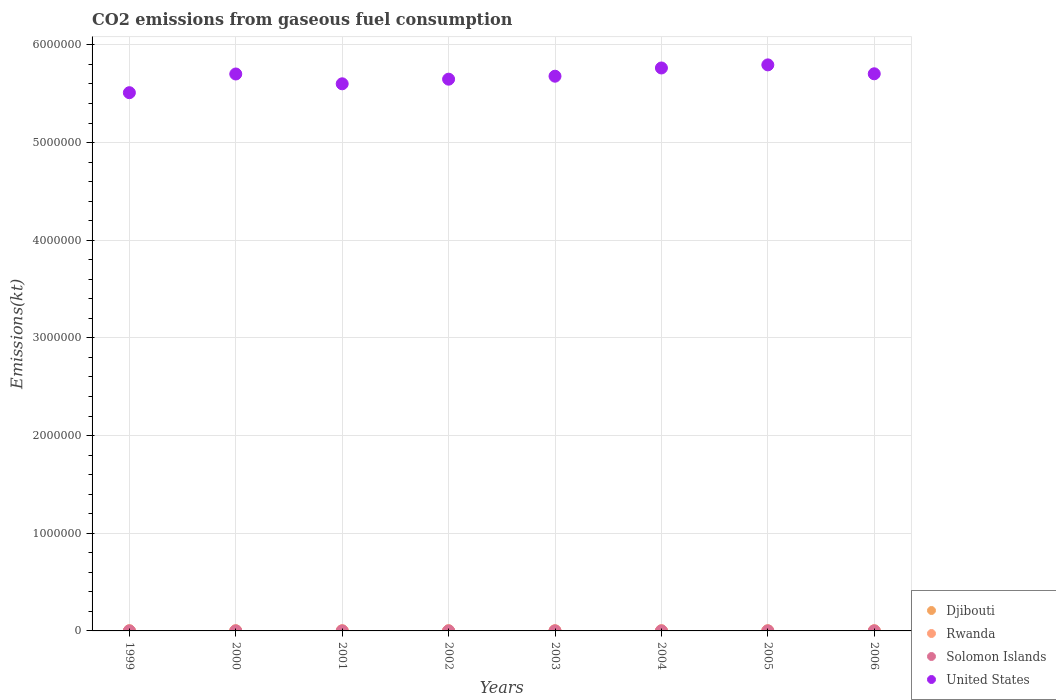How many different coloured dotlines are there?
Your response must be concise. 4. What is the amount of CO2 emitted in Solomon Islands in 2003?
Provide a short and direct response. 179.68. Across all years, what is the maximum amount of CO2 emitted in United States?
Provide a short and direct response. 5.80e+06. Across all years, what is the minimum amount of CO2 emitted in Rwanda?
Give a very brief answer. 509.71. In which year was the amount of CO2 emitted in United States maximum?
Ensure brevity in your answer.  2005. In which year was the amount of CO2 emitted in United States minimum?
Keep it short and to the point. 1999. What is the total amount of CO2 emitted in Djibouti in the graph?
Offer a very short reply. 3197.62. What is the difference between the amount of CO2 emitted in Djibouti in 1999 and that in 2004?
Offer a very short reply. 11. What is the difference between the amount of CO2 emitted in United States in 2001 and the amount of CO2 emitted in Solomon Islands in 2005?
Give a very brief answer. 5.60e+06. What is the average amount of CO2 emitted in Rwanda per year?
Provide a succinct answer. 525.76. In the year 2001, what is the difference between the amount of CO2 emitted in Djibouti and amount of CO2 emitted in Rwanda?
Ensure brevity in your answer.  -205.35. What is the ratio of the amount of CO2 emitted in Rwanda in 2002 to that in 2006?
Your answer should be compact. 1.01. What is the difference between the highest and the second highest amount of CO2 emitted in United States?
Your response must be concise. 3.17e+04. What is the difference between the highest and the lowest amount of CO2 emitted in Rwanda?
Provide a succinct answer. 22. In how many years, is the amount of CO2 emitted in United States greater than the average amount of CO2 emitted in United States taken over all years?
Give a very brief answer. 5. Is it the case that in every year, the sum of the amount of CO2 emitted in Rwanda and amount of CO2 emitted in Solomon Islands  is greater than the amount of CO2 emitted in United States?
Your answer should be compact. No. Is the amount of CO2 emitted in Djibouti strictly greater than the amount of CO2 emitted in Solomon Islands over the years?
Your answer should be very brief. Yes. How many dotlines are there?
Ensure brevity in your answer.  4. Are the values on the major ticks of Y-axis written in scientific E-notation?
Make the answer very short. No. Does the graph contain grids?
Provide a short and direct response. Yes. How many legend labels are there?
Keep it short and to the point. 4. What is the title of the graph?
Ensure brevity in your answer.  CO2 emissions from gaseous fuel consumption. What is the label or title of the Y-axis?
Your answer should be very brief. Emissions(kt). What is the Emissions(kt) in Djibouti in 1999?
Your response must be concise. 421.7. What is the Emissions(kt) in Rwanda in 1999?
Your answer should be very brief. 509.71. What is the Emissions(kt) of Solomon Islands in 1999?
Your answer should be very brief. 165.01. What is the Emissions(kt) in United States in 1999?
Provide a short and direct response. 5.51e+06. What is the Emissions(kt) of Djibouti in 2000?
Provide a succinct answer. 363.03. What is the Emissions(kt) in Rwanda in 2000?
Your answer should be very brief. 528.05. What is the Emissions(kt) of Solomon Islands in 2000?
Give a very brief answer. 165.01. What is the Emissions(kt) of United States in 2000?
Your answer should be compact. 5.70e+06. What is the Emissions(kt) of Djibouti in 2001?
Provide a succinct answer. 326.36. What is the Emissions(kt) of Rwanda in 2001?
Make the answer very short. 531.72. What is the Emissions(kt) in Solomon Islands in 2001?
Your answer should be very brief. 172.35. What is the Emissions(kt) of United States in 2001?
Your answer should be compact. 5.60e+06. What is the Emissions(kt) of Djibouti in 2002?
Offer a terse response. 407.04. What is the Emissions(kt) of Rwanda in 2002?
Give a very brief answer. 531.72. What is the Emissions(kt) in Solomon Islands in 2002?
Ensure brevity in your answer.  172.35. What is the Emissions(kt) in United States in 2002?
Offer a very short reply. 5.65e+06. What is the Emissions(kt) of Djibouti in 2003?
Your answer should be compact. 429.04. What is the Emissions(kt) in Rwanda in 2003?
Keep it short and to the point. 520.71. What is the Emissions(kt) in Solomon Islands in 2003?
Keep it short and to the point. 179.68. What is the Emissions(kt) of United States in 2003?
Ensure brevity in your answer.  5.68e+06. What is the Emissions(kt) of Djibouti in 2004?
Make the answer very short. 410.7. What is the Emissions(kt) in Rwanda in 2004?
Your answer should be compact. 528.05. What is the Emissions(kt) in Solomon Islands in 2004?
Your answer should be compact. 179.68. What is the Emissions(kt) in United States in 2004?
Offer a terse response. 5.76e+06. What is the Emissions(kt) in Djibouti in 2005?
Provide a succinct answer. 421.7. What is the Emissions(kt) in Rwanda in 2005?
Offer a very short reply. 528.05. What is the Emissions(kt) of Solomon Islands in 2005?
Make the answer very short. 179.68. What is the Emissions(kt) of United States in 2005?
Ensure brevity in your answer.  5.80e+06. What is the Emissions(kt) in Djibouti in 2006?
Offer a terse response. 418.04. What is the Emissions(kt) in Rwanda in 2006?
Provide a succinct answer. 528.05. What is the Emissions(kt) of Solomon Islands in 2006?
Offer a terse response. 179.68. What is the Emissions(kt) in United States in 2006?
Provide a short and direct response. 5.70e+06. Across all years, what is the maximum Emissions(kt) of Djibouti?
Keep it short and to the point. 429.04. Across all years, what is the maximum Emissions(kt) in Rwanda?
Give a very brief answer. 531.72. Across all years, what is the maximum Emissions(kt) of Solomon Islands?
Give a very brief answer. 179.68. Across all years, what is the maximum Emissions(kt) of United States?
Ensure brevity in your answer.  5.80e+06. Across all years, what is the minimum Emissions(kt) in Djibouti?
Provide a short and direct response. 326.36. Across all years, what is the minimum Emissions(kt) of Rwanda?
Your answer should be very brief. 509.71. Across all years, what is the minimum Emissions(kt) of Solomon Islands?
Make the answer very short. 165.01. Across all years, what is the minimum Emissions(kt) of United States?
Ensure brevity in your answer.  5.51e+06. What is the total Emissions(kt) of Djibouti in the graph?
Give a very brief answer. 3197.62. What is the total Emissions(kt) of Rwanda in the graph?
Offer a very short reply. 4206.05. What is the total Emissions(kt) of Solomon Islands in the graph?
Ensure brevity in your answer.  1393.46. What is the total Emissions(kt) of United States in the graph?
Ensure brevity in your answer.  4.54e+07. What is the difference between the Emissions(kt) of Djibouti in 1999 and that in 2000?
Ensure brevity in your answer.  58.67. What is the difference between the Emissions(kt) in Rwanda in 1999 and that in 2000?
Give a very brief answer. -18.34. What is the difference between the Emissions(kt) in Solomon Islands in 1999 and that in 2000?
Give a very brief answer. 0. What is the difference between the Emissions(kt) in United States in 1999 and that in 2000?
Your answer should be compact. -1.91e+05. What is the difference between the Emissions(kt) in Djibouti in 1999 and that in 2001?
Offer a terse response. 95.34. What is the difference between the Emissions(kt) in Rwanda in 1999 and that in 2001?
Provide a succinct answer. -22. What is the difference between the Emissions(kt) of Solomon Islands in 1999 and that in 2001?
Offer a very short reply. -7.33. What is the difference between the Emissions(kt) of United States in 1999 and that in 2001?
Your answer should be very brief. -9.10e+04. What is the difference between the Emissions(kt) of Djibouti in 1999 and that in 2002?
Offer a very short reply. 14.67. What is the difference between the Emissions(kt) in Rwanda in 1999 and that in 2002?
Offer a very short reply. -22. What is the difference between the Emissions(kt) of Solomon Islands in 1999 and that in 2002?
Your response must be concise. -7.33. What is the difference between the Emissions(kt) in United States in 1999 and that in 2002?
Provide a short and direct response. -1.38e+05. What is the difference between the Emissions(kt) in Djibouti in 1999 and that in 2003?
Give a very brief answer. -7.33. What is the difference between the Emissions(kt) in Rwanda in 1999 and that in 2003?
Give a very brief answer. -11. What is the difference between the Emissions(kt) in Solomon Islands in 1999 and that in 2003?
Provide a succinct answer. -14.67. What is the difference between the Emissions(kt) in United States in 1999 and that in 2003?
Provide a short and direct response. -1.69e+05. What is the difference between the Emissions(kt) in Djibouti in 1999 and that in 2004?
Make the answer very short. 11. What is the difference between the Emissions(kt) in Rwanda in 1999 and that in 2004?
Make the answer very short. -18.34. What is the difference between the Emissions(kt) in Solomon Islands in 1999 and that in 2004?
Offer a terse response. -14.67. What is the difference between the Emissions(kt) in United States in 1999 and that in 2004?
Provide a succinct answer. -2.53e+05. What is the difference between the Emissions(kt) in Rwanda in 1999 and that in 2005?
Keep it short and to the point. -18.34. What is the difference between the Emissions(kt) of Solomon Islands in 1999 and that in 2005?
Your response must be concise. -14.67. What is the difference between the Emissions(kt) of United States in 1999 and that in 2005?
Offer a very short reply. -2.85e+05. What is the difference between the Emissions(kt) in Djibouti in 1999 and that in 2006?
Your answer should be very brief. 3.67. What is the difference between the Emissions(kt) in Rwanda in 1999 and that in 2006?
Provide a succinct answer. -18.34. What is the difference between the Emissions(kt) of Solomon Islands in 1999 and that in 2006?
Provide a short and direct response. -14.67. What is the difference between the Emissions(kt) of United States in 1999 and that in 2006?
Ensure brevity in your answer.  -1.93e+05. What is the difference between the Emissions(kt) of Djibouti in 2000 and that in 2001?
Make the answer very short. 36.67. What is the difference between the Emissions(kt) in Rwanda in 2000 and that in 2001?
Keep it short and to the point. -3.67. What is the difference between the Emissions(kt) of Solomon Islands in 2000 and that in 2001?
Give a very brief answer. -7.33. What is the difference between the Emissions(kt) in United States in 2000 and that in 2001?
Your response must be concise. 1.00e+05. What is the difference between the Emissions(kt) in Djibouti in 2000 and that in 2002?
Your response must be concise. -44. What is the difference between the Emissions(kt) of Rwanda in 2000 and that in 2002?
Your answer should be very brief. -3.67. What is the difference between the Emissions(kt) in Solomon Islands in 2000 and that in 2002?
Make the answer very short. -7.33. What is the difference between the Emissions(kt) in United States in 2000 and that in 2002?
Provide a succinct answer. 5.31e+04. What is the difference between the Emissions(kt) of Djibouti in 2000 and that in 2003?
Make the answer very short. -66.01. What is the difference between the Emissions(kt) in Rwanda in 2000 and that in 2003?
Your response must be concise. 7.33. What is the difference between the Emissions(kt) of Solomon Islands in 2000 and that in 2003?
Offer a very short reply. -14.67. What is the difference between the Emissions(kt) of United States in 2000 and that in 2003?
Your answer should be very brief. 2.26e+04. What is the difference between the Emissions(kt) of Djibouti in 2000 and that in 2004?
Keep it short and to the point. -47.67. What is the difference between the Emissions(kt) in Solomon Islands in 2000 and that in 2004?
Offer a very short reply. -14.67. What is the difference between the Emissions(kt) of United States in 2000 and that in 2004?
Provide a short and direct response. -6.16e+04. What is the difference between the Emissions(kt) in Djibouti in 2000 and that in 2005?
Provide a short and direct response. -58.67. What is the difference between the Emissions(kt) of Solomon Islands in 2000 and that in 2005?
Provide a succinct answer. -14.67. What is the difference between the Emissions(kt) in United States in 2000 and that in 2005?
Your answer should be very brief. -9.33e+04. What is the difference between the Emissions(kt) of Djibouti in 2000 and that in 2006?
Give a very brief answer. -55.01. What is the difference between the Emissions(kt) in Rwanda in 2000 and that in 2006?
Provide a short and direct response. 0. What is the difference between the Emissions(kt) of Solomon Islands in 2000 and that in 2006?
Give a very brief answer. -14.67. What is the difference between the Emissions(kt) in United States in 2000 and that in 2006?
Your answer should be very brief. -2042.52. What is the difference between the Emissions(kt) of Djibouti in 2001 and that in 2002?
Make the answer very short. -80.67. What is the difference between the Emissions(kt) of United States in 2001 and that in 2002?
Give a very brief answer. -4.73e+04. What is the difference between the Emissions(kt) in Djibouti in 2001 and that in 2003?
Give a very brief answer. -102.68. What is the difference between the Emissions(kt) of Rwanda in 2001 and that in 2003?
Offer a very short reply. 11. What is the difference between the Emissions(kt) of Solomon Islands in 2001 and that in 2003?
Your response must be concise. -7.33. What is the difference between the Emissions(kt) of United States in 2001 and that in 2003?
Ensure brevity in your answer.  -7.78e+04. What is the difference between the Emissions(kt) of Djibouti in 2001 and that in 2004?
Ensure brevity in your answer.  -84.34. What is the difference between the Emissions(kt) in Rwanda in 2001 and that in 2004?
Provide a short and direct response. 3.67. What is the difference between the Emissions(kt) of Solomon Islands in 2001 and that in 2004?
Offer a terse response. -7.33. What is the difference between the Emissions(kt) in United States in 2001 and that in 2004?
Make the answer very short. -1.62e+05. What is the difference between the Emissions(kt) in Djibouti in 2001 and that in 2005?
Ensure brevity in your answer.  -95.34. What is the difference between the Emissions(kt) of Rwanda in 2001 and that in 2005?
Give a very brief answer. 3.67. What is the difference between the Emissions(kt) of Solomon Islands in 2001 and that in 2005?
Offer a very short reply. -7.33. What is the difference between the Emissions(kt) of United States in 2001 and that in 2005?
Offer a terse response. -1.94e+05. What is the difference between the Emissions(kt) in Djibouti in 2001 and that in 2006?
Offer a terse response. -91.67. What is the difference between the Emissions(kt) in Rwanda in 2001 and that in 2006?
Your response must be concise. 3.67. What is the difference between the Emissions(kt) of Solomon Islands in 2001 and that in 2006?
Your answer should be compact. -7.33. What is the difference between the Emissions(kt) in United States in 2001 and that in 2006?
Provide a succinct answer. -1.02e+05. What is the difference between the Emissions(kt) in Djibouti in 2002 and that in 2003?
Provide a succinct answer. -22. What is the difference between the Emissions(kt) in Rwanda in 2002 and that in 2003?
Give a very brief answer. 11. What is the difference between the Emissions(kt) of Solomon Islands in 2002 and that in 2003?
Keep it short and to the point. -7.33. What is the difference between the Emissions(kt) of United States in 2002 and that in 2003?
Your answer should be very brief. -3.05e+04. What is the difference between the Emissions(kt) of Djibouti in 2002 and that in 2004?
Keep it short and to the point. -3.67. What is the difference between the Emissions(kt) of Rwanda in 2002 and that in 2004?
Ensure brevity in your answer.  3.67. What is the difference between the Emissions(kt) in Solomon Islands in 2002 and that in 2004?
Provide a succinct answer. -7.33. What is the difference between the Emissions(kt) of United States in 2002 and that in 2004?
Your answer should be compact. -1.15e+05. What is the difference between the Emissions(kt) of Djibouti in 2002 and that in 2005?
Your answer should be compact. -14.67. What is the difference between the Emissions(kt) of Rwanda in 2002 and that in 2005?
Keep it short and to the point. 3.67. What is the difference between the Emissions(kt) of Solomon Islands in 2002 and that in 2005?
Provide a succinct answer. -7.33. What is the difference between the Emissions(kt) in United States in 2002 and that in 2005?
Provide a short and direct response. -1.46e+05. What is the difference between the Emissions(kt) of Djibouti in 2002 and that in 2006?
Your response must be concise. -11. What is the difference between the Emissions(kt) of Rwanda in 2002 and that in 2006?
Give a very brief answer. 3.67. What is the difference between the Emissions(kt) of Solomon Islands in 2002 and that in 2006?
Provide a succinct answer. -7.33. What is the difference between the Emissions(kt) in United States in 2002 and that in 2006?
Keep it short and to the point. -5.51e+04. What is the difference between the Emissions(kt) of Djibouti in 2003 and that in 2004?
Make the answer very short. 18.34. What is the difference between the Emissions(kt) of Rwanda in 2003 and that in 2004?
Offer a very short reply. -7.33. What is the difference between the Emissions(kt) of Solomon Islands in 2003 and that in 2004?
Offer a terse response. 0. What is the difference between the Emissions(kt) in United States in 2003 and that in 2004?
Provide a succinct answer. -8.42e+04. What is the difference between the Emissions(kt) in Djibouti in 2003 and that in 2005?
Make the answer very short. 7.33. What is the difference between the Emissions(kt) of Rwanda in 2003 and that in 2005?
Your answer should be compact. -7.33. What is the difference between the Emissions(kt) of United States in 2003 and that in 2005?
Keep it short and to the point. -1.16e+05. What is the difference between the Emissions(kt) of Djibouti in 2003 and that in 2006?
Provide a succinct answer. 11. What is the difference between the Emissions(kt) of Rwanda in 2003 and that in 2006?
Keep it short and to the point. -7.33. What is the difference between the Emissions(kt) in United States in 2003 and that in 2006?
Your answer should be very brief. -2.46e+04. What is the difference between the Emissions(kt) in Djibouti in 2004 and that in 2005?
Offer a terse response. -11. What is the difference between the Emissions(kt) in Rwanda in 2004 and that in 2005?
Make the answer very short. 0. What is the difference between the Emissions(kt) in United States in 2004 and that in 2005?
Your answer should be very brief. -3.17e+04. What is the difference between the Emissions(kt) of Djibouti in 2004 and that in 2006?
Provide a succinct answer. -7.33. What is the difference between the Emissions(kt) of Rwanda in 2004 and that in 2006?
Offer a terse response. 0. What is the difference between the Emissions(kt) of Solomon Islands in 2004 and that in 2006?
Provide a succinct answer. 0. What is the difference between the Emissions(kt) of United States in 2004 and that in 2006?
Offer a very short reply. 5.96e+04. What is the difference between the Emissions(kt) of Djibouti in 2005 and that in 2006?
Offer a very short reply. 3.67. What is the difference between the Emissions(kt) of Rwanda in 2005 and that in 2006?
Your answer should be very brief. 0. What is the difference between the Emissions(kt) of Solomon Islands in 2005 and that in 2006?
Give a very brief answer. 0. What is the difference between the Emissions(kt) in United States in 2005 and that in 2006?
Give a very brief answer. 9.13e+04. What is the difference between the Emissions(kt) in Djibouti in 1999 and the Emissions(kt) in Rwanda in 2000?
Give a very brief answer. -106.34. What is the difference between the Emissions(kt) of Djibouti in 1999 and the Emissions(kt) of Solomon Islands in 2000?
Make the answer very short. 256.69. What is the difference between the Emissions(kt) of Djibouti in 1999 and the Emissions(kt) of United States in 2000?
Ensure brevity in your answer.  -5.70e+06. What is the difference between the Emissions(kt) in Rwanda in 1999 and the Emissions(kt) in Solomon Islands in 2000?
Your answer should be compact. 344.7. What is the difference between the Emissions(kt) in Rwanda in 1999 and the Emissions(kt) in United States in 2000?
Your answer should be very brief. -5.70e+06. What is the difference between the Emissions(kt) in Solomon Islands in 1999 and the Emissions(kt) in United States in 2000?
Provide a succinct answer. -5.70e+06. What is the difference between the Emissions(kt) of Djibouti in 1999 and the Emissions(kt) of Rwanda in 2001?
Keep it short and to the point. -110.01. What is the difference between the Emissions(kt) in Djibouti in 1999 and the Emissions(kt) in Solomon Islands in 2001?
Offer a very short reply. 249.36. What is the difference between the Emissions(kt) of Djibouti in 1999 and the Emissions(kt) of United States in 2001?
Ensure brevity in your answer.  -5.60e+06. What is the difference between the Emissions(kt) in Rwanda in 1999 and the Emissions(kt) in Solomon Islands in 2001?
Provide a succinct answer. 337.36. What is the difference between the Emissions(kt) of Rwanda in 1999 and the Emissions(kt) of United States in 2001?
Keep it short and to the point. -5.60e+06. What is the difference between the Emissions(kt) in Solomon Islands in 1999 and the Emissions(kt) in United States in 2001?
Make the answer very short. -5.60e+06. What is the difference between the Emissions(kt) in Djibouti in 1999 and the Emissions(kt) in Rwanda in 2002?
Provide a short and direct response. -110.01. What is the difference between the Emissions(kt) of Djibouti in 1999 and the Emissions(kt) of Solomon Islands in 2002?
Your response must be concise. 249.36. What is the difference between the Emissions(kt) of Djibouti in 1999 and the Emissions(kt) of United States in 2002?
Your answer should be compact. -5.65e+06. What is the difference between the Emissions(kt) of Rwanda in 1999 and the Emissions(kt) of Solomon Islands in 2002?
Provide a succinct answer. 337.36. What is the difference between the Emissions(kt) of Rwanda in 1999 and the Emissions(kt) of United States in 2002?
Make the answer very short. -5.65e+06. What is the difference between the Emissions(kt) in Solomon Islands in 1999 and the Emissions(kt) in United States in 2002?
Offer a terse response. -5.65e+06. What is the difference between the Emissions(kt) in Djibouti in 1999 and the Emissions(kt) in Rwanda in 2003?
Your response must be concise. -99.01. What is the difference between the Emissions(kt) in Djibouti in 1999 and the Emissions(kt) in Solomon Islands in 2003?
Provide a short and direct response. 242.02. What is the difference between the Emissions(kt) in Djibouti in 1999 and the Emissions(kt) in United States in 2003?
Make the answer very short. -5.68e+06. What is the difference between the Emissions(kt) of Rwanda in 1999 and the Emissions(kt) of Solomon Islands in 2003?
Make the answer very short. 330.03. What is the difference between the Emissions(kt) of Rwanda in 1999 and the Emissions(kt) of United States in 2003?
Offer a terse response. -5.68e+06. What is the difference between the Emissions(kt) in Solomon Islands in 1999 and the Emissions(kt) in United States in 2003?
Offer a terse response. -5.68e+06. What is the difference between the Emissions(kt) in Djibouti in 1999 and the Emissions(kt) in Rwanda in 2004?
Your answer should be compact. -106.34. What is the difference between the Emissions(kt) in Djibouti in 1999 and the Emissions(kt) in Solomon Islands in 2004?
Your answer should be very brief. 242.02. What is the difference between the Emissions(kt) in Djibouti in 1999 and the Emissions(kt) in United States in 2004?
Your response must be concise. -5.76e+06. What is the difference between the Emissions(kt) of Rwanda in 1999 and the Emissions(kt) of Solomon Islands in 2004?
Your answer should be very brief. 330.03. What is the difference between the Emissions(kt) of Rwanda in 1999 and the Emissions(kt) of United States in 2004?
Your answer should be very brief. -5.76e+06. What is the difference between the Emissions(kt) of Solomon Islands in 1999 and the Emissions(kt) of United States in 2004?
Ensure brevity in your answer.  -5.76e+06. What is the difference between the Emissions(kt) in Djibouti in 1999 and the Emissions(kt) in Rwanda in 2005?
Make the answer very short. -106.34. What is the difference between the Emissions(kt) in Djibouti in 1999 and the Emissions(kt) in Solomon Islands in 2005?
Your answer should be very brief. 242.02. What is the difference between the Emissions(kt) of Djibouti in 1999 and the Emissions(kt) of United States in 2005?
Provide a short and direct response. -5.79e+06. What is the difference between the Emissions(kt) in Rwanda in 1999 and the Emissions(kt) in Solomon Islands in 2005?
Ensure brevity in your answer.  330.03. What is the difference between the Emissions(kt) of Rwanda in 1999 and the Emissions(kt) of United States in 2005?
Offer a very short reply. -5.79e+06. What is the difference between the Emissions(kt) of Solomon Islands in 1999 and the Emissions(kt) of United States in 2005?
Offer a terse response. -5.79e+06. What is the difference between the Emissions(kt) in Djibouti in 1999 and the Emissions(kt) in Rwanda in 2006?
Offer a very short reply. -106.34. What is the difference between the Emissions(kt) of Djibouti in 1999 and the Emissions(kt) of Solomon Islands in 2006?
Keep it short and to the point. 242.02. What is the difference between the Emissions(kt) of Djibouti in 1999 and the Emissions(kt) of United States in 2006?
Keep it short and to the point. -5.70e+06. What is the difference between the Emissions(kt) in Rwanda in 1999 and the Emissions(kt) in Solomon Islands in 2006?
Your answer should be compact. 330.03. What is the difference between the Emissions(kt) in Rwanda in 1999 and the Emissions(kt) in United States in 2006?
Ensure brevity in your answer.  -5.70e+06. What is the difference between the Emissions(kt) of Solomon Islands in 1999 and the Emissions(kt) of United States in 2006?
Provide a succinct answer. -5.70e+06. What is the difference between the Emissions(kt) in Djibouti in 2000 and the Emissions(kt) in Rwanda in 2001?
Provide a succinct answer. -168.68. What is the difference between the Emissions(kt) of Djibouti in 2000 and the Emissions(kt) of Solomon Islands in 2001?
Ensure brevity in your answer.  190.68. What is the difference between the Emissions(kt) in Djibouti in 2000 and the Emissions(kt) in United States in 2001?
Your response must be concise. -5.60e+06. What is the difference between the Emissions(kt) in Rwanda in 2000 and the Emissions(kt) in Solomon Islands in 2001?
Provide a succinct answer. 355.7. What is the difference between the Emissions(kt) in Rwanda in 2000 and the Emissions(kt) in United States in 2001?
Make the answer very short. -5.60e+06. What is the difference between the Emissions(kt) of Solomon Islands in 2000 and the Emissions(kt) of United States in 2001?
Make the answer very short. -5.60e+06. What is the difference between the Emissions(kt) in Djibouti in 2000 and the Emissions(kt) in Rwanda in 2002?
Offer a very short reply. -168.68. What is the difference between the Emissions(kt) of Djibouti in 2000 and the Emissions(kt) of Solomon Islands in 2002?
Provide a short and direct response. 190.68. What is the difference between the Emissions(kt) in Djibouti in 2000 and the Emissions(kt) in United States in 2002?
Ensure brevity in your answer.  -5.65e+06. What is the difference between the Emissions(kt) of Rwanda in 2000 and the Emissions(kt) of Solomon Islands in 2002?
Make the answer very short. 355.7. What is the difference between the Emissions(kt) of Rwanda in 2000 and the Emissions(kt) of United States in 2002?
Provide a succinct answer. -5.65e+06. What is the difference between the Emissions(kt) of Solomon Islands in 2000 and the Emissions(kt) of United States in 2002?
Your answer should be compact. -5.65e+06. What is the difference between the Emissions(kt) in Djibouti in 2000 and the Emissions(kt) in Rwanda in 2003?
Offer a very short reply. -157.68. What is the difference between the Emissions(kt) in Djibouti in 2000 and the Emissions(kt) in Solomon Islands in 2003?
Your answer should be compact. 183.35. What is the difference between the Emissions(kt) of Djibouti in 2000 and the Emissions(kt) of United States in 2003?
Offer a terse response. -5.68e+06. What is the difference between the Emissions(kt) of Rwanda in 2000 and the Emissions(kt) of Solomon Islands in 2003?
Offer a terse response. 348.37. What is the difference between the Emissions(kt) of Rwanda in 2000 and the Emissions(kt) of United States in 2003?
Provide a short and direct response. -5.68e+06. What is the difference between the Emissions(kt) of Solomon Islands in 2000 and the Emissions(kt) of United States in 2003?
Offer a terse response. -5.68e+06. What is the difference between the Emissions(kt) of Djibouti in 2000 and the Emissions(kt) of Rwanda in 2004?
Provide a succinct answer. -165.01. What is the difference between the Emissions(kt) of Djibouti in 2000 and the Emissions(kt) of Solomon Islands in 2004?
Offer a terse response. 183.35. What is the difference between the Emissions(kt) of Djibouti in 2000 and the Emissions(kt) of United States in 2004?
Keep it short and to the point. -5.76e+06. What is the difference between the Emissions(kt) in Rwanda in 2000 and the Emissions(kt) in Solomon Islands in 2004?
Provide a succinct answer. 348.37. What is the difference between the Emissions(kt) in Rwanda in 2000 and the Emissions(kt) in United States in 2004?
Ensure brevity in your answer.  -5.76e+06. What is the difference between the Emissions(kt) of Solomon Islands in 2000 and the Emissions(kt) of United States in 2004?
Offer a terse response. -5.76e+06. What is the difference between the Emissions(kt) of Djibouti in 2000 and the Emissions(kt) of Rwanda in 2005?
Your answer should be very brief. -165.01. What is the difference between the Emissions(kt) of Djibouti in 2000 and the Emissions(kt) of Solomon Islands in 2005?
Make the answer very short. 183.35. What is the difference between the Emissions(kt) of Djibouti in 2000 and the Emissions(kt) of United States in 2005?
Your answer should be compact. -5.79e+06. What is the difference between the Emissions(kt) of Rwanda in 2000 and the Emissions(kt) of Solomon Islands in 2005?
Your answer should be very brief. 348.37. What is the difference between the Emissions(kt) of Rwanda in 2000 and the Emissions(kt) of United States in 2005?
Offer a very short reply. -5.79e+06. What is the difference between the Emissions(kt) of Solomon Islands in 2000 and the Emissions(kt) of United States in 2005?
Provide a short and direct response. -5.79e+06. What is the difference between the Emissions(kt) in Djibouti in 2000 and the Emissions(kt) in Rwanda in 2006?
Make the answer very short. -165.01. What is the difference between the Emissions(kt) in Djibouti in 2000 and the Emissions(kt) in Solomon Islands in 2006?
Your answer should be very brief. 183.35. What is the difference between the Emissions(kt) in Djibouti in 2000 and the Emissions(kt) in United States in 2006?
Ensure brevity in your answer.  -5.70e+06. What is the difference between the Emissions(kt) in Rwanda in 2000 and the Emissions(kt) in Solomon Islands in 2006?
Offer a terse response. 348.37. What is the difference between the Emissions(kt) of Rwanda in 2000 and the Emissions(kt) of United States in 2006?
Your answer should be very brief. -5.70e+06. What is the difference between the Emissions(kt) in Solomon Islands in 2000 and the Emissions(kt) in United States in 2006?
Offer a very short reply. -5.70e+06. What is the difference between the Emissions(kt) of Djibouti in 2001 and the Emissions(kt) of Rwanda in 2002?
Provide a short and direct response. -205.35. What is the difference between the Emissions(kt) of Djibouti in 2001 and the Emissions(kt) of Solomon Islands in 2002?
Your answer should be compact. 154.01. What is the difference between the Emissions(kt) in Djibouti in 2001 and the Emissions(kt) in United States in 2002?
Provide a short and direct response. -5.65e+06. What is the difference between the Emissions(kt) of Rwanda in 2001 and the Emissions(kt) of Solomon Islands in 2002?
Ensure brevity in your answer.  359.37. What is the difference between the Emissions(kt) of Rwanda in 2001 and the Emissions(kt) of United States in 2002?
Give a very brief answer. -5.65e+06. What is the difference between the Emissions(kt) in Solomon Islands in 2001 and the Emissions(kt) in United States in 2002?
Ensure brevity in your answer.  -5.65e+06. What is the difference between the Emissions(kt) of Djibouti in 2001 and the Emissions(kt) of Rwanda in 2003?
Provide a short and direct response. -194.35. What is the difference between the Emissions(kt) in Djibouti in 2001 and the Emissions(kt) in Solomon Islands in 2003?
Offer a very short reply. 146.68. What is the difference between the Emissions(kt) in Djibouti in 2001 and the Emissions(kt) in United States in 2003?
Your answer should be compact. -5.68e+06. What is the difference between the Emissions(kt) of Rwanda in 2001 and the Emissions(kt) of Solomon Islands in 2003?
Provide a succinct answer. 352.03. What is the difference between the Emissions(kt) in Rwanda in 2001 and the Emissions(kt) in United States in 2003?
Your answer should be compact. -5.68e+06. What is the difference between the Emissions(kt) of Solomon Islands in 2001 and the Emissions(kt) of United States in 2003?
Give a very brief answer. -5.68e+06. What is the difference between the Emissions(kt) of Djibouti in 2001 and the Emissions(kt) of Rwanda in 2004?
Provide a succinct answer. -201.69. What is the difference between the Emissions(kt) in Djibouti in 2001 and the Emissions(kt) in Solomon Islands in 2004?
Give a very brief answer. 146.68. What is the difference between the Emissions(kt) of Djibouti in 2001 and the Emissions(kt) of United States in 2004?
Provide a succinct answer. -5.76e+06. What is the difference between the Emissions(kt) in Rwanda in 2001 and the Emissions(kt) in Solomon Islands in 2004?
Provide a short and direct response. 352.03. What is the difference between the Emissions(kt) in Rwanda in 2001 and the Emissions(kt) in United States in 2004?
Give a very brief answer. -5.76e+06. What is the difference between the Emissions(kt) in Solomon Islands in 2001 and the Emissions(kt) in United States in 2004?
Your response must be concise. -5.76e+06. What is the difference between the Emissions(kt) in Djibouti in 2001 and the Emissions(kt) in Rwanda in 2005?
Offer a terse response. -201.69. What is the difference between the Emissions(kt) of Djibouti in 2001 and the Emissions(kt) of Solomon Islands in 2005?
Offer a terse response. 146.68. What is the difference between the Emissions(kt) of Djibouti in 2001 and the Emissions(kt) of United States in 2005?
Ensure brevity in your answer.  -5.79e+06. What is the difference between the Emissions(kt) of Rwanda in 2001 and the Emissions(kt) of Solomon Islands in 2005?
Your answer should be compact. 352.03. What is the difference between the Emissions(kt) in Rwanda in 2001 and the Emissions(kt) in United States in 2005?
Keep it short and to the point. -5.79e+06. What is the difference between the Emissions(kt) of Solomon Islands in 2001 and the Emissions(kt) of United States in 2005?
Offer a terse response. -5.79e+06. What is the difference between the Emissions(kt) of Djibouti in 2001 and the Emissions(kt) of Rwanda in 2006?
Provide a succinct answer. -201.69. What is the difference between the Emissions(kt) in Djibouti in 2001 and the Emissions(kt) in Solomon Islands in 2006?
Keep it short and to the point. 146.68. What is the difference between the Emissions(kt) of Djibouti in 2001 and the Emissions(kt) of United States in 2006?
Your answer should be very brief. -5.70e+06. What is the difference between the Emissions(kt) in Rwanda in 2001 and the Emissions(kt) in Solomon Islands in 2006?
Keep it short and to the point. 352.03. What is the difference between the Emissions(kt) in Rwanda in 2001 and the Emissions(kt) in United States in 2006?
Offer a very short reply. -5.70e+06. What is the difference between the Emissions(kt) of Solomon Islands in 2001 and the Emissions(kt) of United States in 2006?
Provide a succinct answer. -5.70e+06. What is the difference between the Emissions(kt) in Djibouti in 2002 and the Emissions(kt) in Rwanda in 2003?
Your answer should be very brief. -113.68. What is the difference between the Emissions(kt) of Djibouti in 2002 and the Emissions(kt) of Solomon Islands in 2003?
Keep it short and to the point. 227.35. What is the difference between the Emissions(kt) of Djibouti in 2002 and the Emissions(kt) of United States in 2003?
Your answer should be very brief. -5.68e+06. What is the difference between the Emissions(kt) in Rwanda in 2002 and the Emissions(kt) in Solomon Islands in 2003?
Your answer should be compact. 352.03. What is the difference between the Emissions(kt) of Rwanda in 2002 and the Emissions(kt) of United States in 2003?
Keep it short and to the point. -5.68e+06. What is the difference between the Emissions(kt) in Solomon Islands in 2002 and the Emissions(kt) in United States in 2003?
Make the answer very short. -5.68e+06. What is the difference between the Emissions(kt) in Djibouti in 2002 and the Emissions(kt) in Rwanda in 2004?
Provide a succinct answer. -121.01. What is the difference between the Emissions(kt) of Djibouti in 2002 and the Emissions(kt) of Solomon Islands in 2004?
Make the answer very short. 227.35. What is the difference between the Emissions(kt) in Djibouti in 2002 and the Emissions(kt) in United States in 2004?
Your answer should be compact. -5.76e+06. What is the difference between the Emissions(kt) of Rwanda in 2002 and the Emissions(kt) of Solomon Islands in 2004?
Make the answer very short. 352.03. What is the difference between the Emissions(kt) in Rwanda in 2002 and the Emissions(kt) in United States in 2004?
Offer a terse response. -5.76e+06. What is the difference between the Emissions(kt) in Solomon Islands in 2002 and the Emissions(kt) in United States in 2004?
Keep it short and to the point. -5.76e+06. What is the difference between the Emissions(kt) of Djibouti in 2002 and the Emissions(kt) of Rwanda in 2005?
Give a very brief answer. -121.01. What is the difference between the Emissions(kt) of Djibouti in 2002 and the Emissions(kt) of Solomon Islands in 2005?
Make the answer very short. 227.35. What is the difference between the Emissions(kt) in Djibouti in 2002 and the Emissions(kt) in United States in 2005?
Offer a very short reply. -5.79e+06. What is the difference between the Emissions(kt) in Rwanda in 2002 and the Emissions(kt) in Solomon Islands in 2005?
Your response must be concise. 352.03. What is the difference between the Emissions(kt) of Rwanda in 2002 and the Emissions(kt) of United States in 2005?
Provide a succinct answer. -5.79e+06. What is the difference between the Emissions(kt) in Solomon Islands in 2002 and the Emissions(kt) in United States in 2005?
Keep it short and to the point. -5.79e+06. What is the difference between the Emissions(kt) in Djibouti in 2002 and the Emissions(kt) in Rwanda in 2006?
Your answer should be compact. -121.01. What is the difference between the Emissions(kt) of Djibouti in 2002 and the Emissions(kt) of Solomon Islands in 2006?
Provide a succinct answer. 227.35. What is the difference between the Emissions(kt) of Djibouti in 2002 and the Emissions(kt) of United States in 2006?
Offer a very short reply. -5.70e+06. What is the difference between the Emissions(kt) of Rwanda in 2002 and the Emissions(kt) of Solomon Islands in 2006?
Your answer should be compact. 352.03. What is the difference between the Emissions(kt) in Rwanda in 2002 and the Emissions(kt) in United States in 2006?
Your answer should be very brief. -5.70e+06. What is the difference between the Emissions(kt) in Solomon Islands in 2002 and the Emissions(kt) in United States in 2006?
Keep it short and to the point. -5.70e+06. What is the difference between the Emissions(kt) of Djibouti in 2003 and the Emissions(kt) of Rwanda in 2004?
Ensure brevity in your answer.  -99.01. What is the difference between the Emissions(kt) in Djibouti in 2003 and the Emissions(kt) in Solomon Islands in 2004?
Provide a succinct answer. 249.36. What is the difference between the Emissions(kt) of Djibouti in 2003 and the Emissions(kt) of United States in 2004?
Offer a terse response. -5.76e+06. What is the difference between the Emissions(kt) in Rwanda in 2003 and the Emissions(kt) in Solomon Islands in 2004?
Your answer should be very brief. 341.03. What is the difference between the Emissions(kt) of Rwanda in 2003 and the Emissions(kt) of United States in 2004?
Ensure brevity in your answer.  -5.76e+06. What is the difference between the Emissions(kt) in Solomon Islands in 2003 and the Emissions(kt) in United States in 2004?
Provide a succinct answer. -5.76e+06. What is the difference between the Emissions(kt) in Djibouti in 2003 and the Emissions(kt) in Rwanda in 2005?
Give a very brief answer. -99.01. What is the difference between the Emissions(kt) in Djibouti in 2003 and the Emissions(kt) in Solomon Islands in 2005?
Keep it short and to the point. 249.36. What is the difference between the Emissions(kt) of Djibouti in 2003 and the Emissions(kt) of United States in 2005?
Offer a very short reply. -5.79e+06. What is the difference between the Emissions(kt) in Rwanda in 2003 and the Emissions(kt) in Solomon Islands in 2005?
Make the answer very short. 341.03. What is the difference between the Emissions(kt) of Rwanda in 2003 and the Emissions(kt) of United States in 2005?
Your answer should be very brief. -5.79e+06. What is the difference between the Emissions(kt) of Solomon Islands in 2003 and the Emissions(kt) of United States in 2005?
Provide a short and direct response. -5.79e+06. What is the difference between the Emissions(kt) of Djibouti in 2003 and the Emissions(kt) of Rwanda in 2006?
Provide a succinct answer. -99.01. What is the difference between the Emissions(kt) in Djibouti in 2003 and the Emissions(kt) in Solomon Islands in 2006?
Provide a short and direct response. 249.36. What is the difference between the Emissions(kt) in Djibouti in 2003 and the Emissions(kt) in United States in 2006?
Your answer should be compact. -5.70e+06. What is the difference between the Emissions(kt) of Rwanda in 2003 and the Emissions(kt) of Solomon Islands in 2006?
Make the answer very short. 341.03. What is the difference between the Emissions(kt) in Rwanda in 2003 and the Emissions(kt) in United States in 2006?
Provide a short and direct response. -5.70e+06. What is the difference between the Emissions(kt) of Solomon Islands in 2003 and the Emissions(kt) of United States in 2006?
Provide a short and direct response. -5.70e+06. What is the difference between the Emissions(kt) in Djibouti in 2004 and the Emissions(kt) in Rwanda in 2005?
Ensure brevity in your answer.  -117.34. What is the difference between the Emissions(kt) of Djibouti in 2004 and the Emissions(kt) of Solomon Islands in 2005?
Your answer should be very brief. 231.02. What is the difference between the Emissions(kt) of Djibouti in 2004 and the Emissions(kt) of United States in 2005?
Provide a short and direct response. -5.79e+06. What is the difference between the Emissions(kt) of Rwanda in 2004 and the Emissions(kt) of Solomon Islands in 2005?
Offer a very short reply. 348.37. What is the difference between the Emissions(kt) in Rwanda in 2004 and the Emissions(kt) in United States in 2005?
Provide a short and direct response. -5.79e+06. What is the difference between the Emissions(kt) in Solomon Islands in 2004 and the Emissions(kt) in United States in 2005?
Offer a very short reply. -5.79e+06. What is the difference between the Emissions(kt) of Djibouti in 2004 and the Emissions(kt) of Rwanda in 2006?
Offer a terse response. -117.34. What is the difference between the Emissions(kt) of Djibouti in 2004 and the Emissions(kt) of Solomon Islands in 2006?
Provide a short and direct response. 231.02. What is the difference between the Emissions(kt) in Djibouti in 2004 and the Emissions(kt) in United States in 2006?
Your answer should be compact. -5.70e+06. What is the difference between the Emissions(kt) in Rwanda in 2004 and the Emissions(kt) in Solomon Islands in 2006?
Keep it short and to the point. 348.37. What is the difference between the Emissions(kt) in Rwanda in 2004 and the Emissions(kt) in United States in 2006?
Your answer should be very brief. -5.70e+06. What is the difference between the Emissions(kt) in Solomon Islands in 2004 and the Emissions(kt) in United States in 2006?
Give a very brief answer. -5.70e+06. What is the difference between the Emissions(kt) in Djibouti in 2005 and the Emissions(kt) in Rwanda in 2006?
Make the answer very short. -106.34. What is the difference between the Emissions(kt) of Djibouti in 2005 and the Emissions(kt) of Solomon Islands in 2006?
Give a very brief answer. 242.02. What is the difference between the Emissions(kt) of Djibouti in 2005 and the Emissions(kt) of United States in 2006?
Provide a succinct answer. -5.70e+06. What is the difference between the Emissions(kt) of Rwanda in 2005 and the Emissions(kt) of Solomon Islands in 2006?
Your answer should be compact. 348.37. What is the difference between the Emissions(kt) in Rwanda in 2005 and the Emissions(kt) in United States in 2006?
Ensure brevity in your answer.  -5.70e+06. What is the difference between the Emissions(kt) in Solomon Islands in 2005 and the Emissions(kt) in United States in 2006?
Make the answer very short. -5.70e+06. What is the average Emissions(kt) of Djibouti per year?
Ensure brevity in your answer.  399.7. What is the average Emissions(kt) in Rwanda per year?
Your answer should be very brief. 525.76. What is the average Emissions(kt) of Solomon Islands per year?
Ensure brevity in your answer.  174.18. What is the average Emissions(kt) in United States per year?
Offer a terse response. 5.68e+06. In the year 1999, what is the difference between the Emissions(kt) in Djibouti and Emissions(kt) in Rwanda?
Your response must be concise. -88.01. In the year 1999, what is the difference between the Emissions(kt) in Djibouti and Emissions(kt) in Solomon Islands?
Make the answer very short. 256.69. In the year 1999, what is the difference between the Emissions(kt) of Djibouti and Emissions(kt) of United States?
Give a very brief answer. -5.51e+06. In the year 1999, what is the difference between the Emissions(kt) in Rwanda and Emissions(kt) in Solomon Islands?
Ensure brevity in your answer.  344.7. In the year 1999, what is the difference between the Emissions(kt) of Rwanda and Emissions(kt) of United States?
Your response must be concise. -5.51e+06. In the year 1999, what is the difference between the Emissions(kt) of Solomon Islands and Emissions(kt) of United States?
Your response must be concise. -5.51e+06. In the year 2000, what is the difference between the Emissions(kt) of Djibouti and Emissions(kt) of Rwanda?
Your answer should be compact. -165.01. In the year 2000, what is the difference between the Emissions(kt) in Djibouti and Emissions(kt) in Solomon Islands?
Your response must be concise. 198.02. In the year 2000, what is the difference between the Emissions(kt) of Djibouti and Emissions(kt) of United States?
Offer a very short reply. -5.70e+06. In the year 2000, what is the difference between the Emissions(kt) of Rwanda and Emissions(kt) of Solomon Islands?
Ensure brevity in your answer.  363.03. In the year 2000, what is the difference between the Emissions(kt) of Rwanda and Emissions(kt) of United States?
Keep it short and to the point. -5.70e+06. In the year 2000, what is the difference between the Emissions(kt) in Solomon Islands and Emissions(kt) in United States?
Your answer should be very brief. -5.70e+06. In the year 2001, what is the difference between the Emissions(kt) in Djibouti and Emissions(kt) in Rwanda?
Give a very brief answer. -205.35. In the year 2001, what is the difference between the Emissions(kt) of Djibouti and Emissions(kt) of Solomon Islands?
Provide a succinct answer. 154.01. In the year 2001, what is the difference between the Emissions(kt) of Djibouti and Emissions(kt) of United States?
Keep it short and to the point. -5.60e+06. In the year 2001, what is the difference between the Emissions(kt) of Rwanda and Emissions(kt) of Solomon Islands?
Give a very brief answer. 359.37. In the year 2001, what is the difference between the Emissions(kt) of Rwanda and Emissions(kt) of United States?
Your answer should be compact. -5.60e+06. In the year 2001, what is the difference between the Emissions(kt) of Solomon Islands and Emissions(kt) of United States?
Give a very brief answer. -5.60e+06. In the year 2002, what is the difference between the Emissions(kt) of Djibouti and Emissions(kt) of Rwanda?
Give a very brief answer. -124.68. In the year 2002, what is the difference between the Emissions(kt) of Djibouti and Emissions(kt) of Solomon Islands?
Give a very brief answer. 234.69. In the year 2002, what is the difference between the Emissions(kt) in Djibouti and Emissions(kt) in United States?
Offer a very short reply. -5.65e+06. In the year 2002, what is the difference between the Emissions(kt) in Rwanda and Emissions(kt) in Solomon Islands?
Provide a succinct answer. 359.37. In the year 2002, what is the difference between the Emissions(kt) of Rwanda and Emissions(kt) of United States?
Your response must be concise. -5.65e+06. In the year 2002, what is the difference between the Emissions(kt) in Solomon Islands and Emissions(kt) in United States?
Offer a terse response. -5.65e+06. In the year 2003, what is the difference between the Emissions(kt) of Djibouti and Emissions(kt) of Rwanda?
Offer a terse response. -91.67. In the year 2003, what is the difference between the Emissions(kt) in Djibouti and Emissions(kt) in Solomon Islands?
Offer a terse response. 249.36. In the year 2003, what is the difference between the Emissions(kt) of Djibouti and Emissions(kt) of United States?
Your response must be concise. -5.68e+06. In the year 2003, what is the difference between the Emissions(kt) of Rwanda and Emissions(kt) of Solomon Islands?
Your response must be concise. 341.03. In the year 2003, what is the difference between the Emissions(kt) in Rwanda and Emissions(kt) in United States?
Keep it short and to the point. -5.68e+06. In the year 2003, what is the difference between the Emissions(kt) in Solomon Islands and Emissions(kt) in United States?
Your answer should be compact. -5.68e+06. In the year 2004, what is the difference between the Emissions(kt) of Djibouti and Emissions(kt) of Rwanda?
Your response must be concise. -117.34. In the year 2004, what is the difference between the Emissions(kt) of Djibouti and Emissions(kt) of Solomon Islands?
Ensure brevity in your answer.  231.02. In the year 2004, what is the difference between the Emissions(kt) in Djibouti and Emissions(kt) in United States?
Provide a succinct answer. -5.76e+06. In the year 2004, what is the difference between the Emissions(kt) in Rwanda and Emissions(kt) in Solomon Islands?
Your answer should be compact. 348.37. In the year 2004, what is the difference between the Emissions(kt) of Rwanda and Emissions(kt) of United States?
Your answer should be compact. -5.76e+06. In the year 2004, what is the difference between the Emissions(kt) of Solomon Islands and Emissions(kt) of United States?
Provide a short and direct response. -5.76e+06. In the year 2005, what is the difference between the Emissions(kt) in Djibouti and Emissions(kt) in Rwanda?
Your response must be concise. -106.34. In the year 2005, what is the difference between the Emissions(kt) in Djibouti and Emissions(kt) in Solomon Islands?
Keep it short and to the point. 242.02. In the year 2005, what is the difference between the Emissions(kt) of Djibouti and Emissions(kt) of United States?
Provide a succinct answer. -5.79e+06. In the year 2005, what is the difference between the Emissions(kt) in Rwanda and Emissions(kt) in Solomon Islands?
Your response must be concise. 348.37. In the year 2005, what is the difference between the Emissions(kt) of Rwanda and Emissions(kt) of United States?
Offer a terse response. -5.79e+06. In the year 2005, what is the difference between the Emissions(kt) of Solomon Islands and Emissions(kt) of United States?
Ensure brevity in your answer.  -5.79e+06. In the year 2006, what is the difference between the Emissions(kt) of Djibouti and Emissions(kt) of Rwanda?
Your answer should be compact. -110.01. In the year 2006, what is the difference between the Emissions(kt) of Djibouti and Emissions(kt) of Solomon Islands?
Offer a terse response. 238.35. In the year 2006, what is the difference between the Emissions(kt) in Djibouti and Emissions(kt) in United States?
Ensure brevity in your answer.  -5.70e+06. In the year 2006, what is the difference between the Emissions(kt) in Rwanda and Emissions(kt) in Solomon Islands?
Offer a very short reply. 348.37. In the year 2006, what is the difference between the Emissions(kt) in Rwanda and Emissions(kt) in United States?
Provide a succinct answer. -5.70e+06. In the year 2006, what is the difference between the Emissions(kt) in Solomon Islands and Emissions(kt) in United States?
Your answer should be compact. -5.70e+06. What is the ratio of the Emissions(kt) of Djibouti in 1999 to that in 2000?
Provide a succinct answer. 1.16. What is the ratio of the Emissions(kt) in Rwanda in 1999 to that in 2000?
Keep it short and to the point. 0.97. What is the ratio of the Emissions(kt) in Solomon Islands in 1999 to that in 2000?
Ensure brevity in your answer.  1. What is the ratio of the Emissions(kt) of United States in 1999 to that in 2000?
Your response must be concise. 0.97. What is the ratio of the Emissions(kt) in Djibouti in 1999 to that in 2001?
Offer a terse response. 1.29. What is the ratio of the Emissions(kt) of Rwanda in 1999 to that in 2001?
Your answer should be compact. 0.96. What is the ratio of the Emissions(kt) of Solomon Islands in 1999 to that in 2001?
Provide a succinct answer. 0.96. What is the ratio of the Emissions(kt) in United States in 1999 to that in 2001?
Provide a short and direct response. 0.98. What is the ratio of the Emissions(kt) of Djibouti in 1999 to that in 2002?
Give a very brief answer. 1.04. What is the ratio of the Emissions(kt) in Rwanda in 1999 to that in 2002?
Make the answer very short. 0.96. What is the ratio of the Emissions(kt) in Solomon Islands in 1999 to that in 2002?
Provide a succinct answer. 0.96. What is the ratio of the Emissions(kt) in United States in 1999 to that in 2002?
Keep it short and to the point. 0.98. What is the ratio of the Emissions(kt) in Djibouti in 1999 to that in 2003?
Your response must be concise. 0.98. What is the ratio of the Emissions(kt) of Rwanda in 1999 to that in 2003?
Offer a very short reply. 0.98. What is the ratio of the Emissions(kt) in Solomon Islands in 1999 to that in 2003?
Offer a very short reply. 0.92. What is the ratio of the Emissions(kt) in United States in 1999 to that in 2003?
Provide a succinct answer. 0.97. What is the ratio of the Emissions(kt) in Djibouti in 1999 to that in 2004?
Keep it short and to the point. 1.03. What is the ratio of the Emissions(kt) of Rwanda in 1999 to that in 2004?
Your answer should be compact. 0.97. What is the ratio of the Emissions(kt) of Solomon Islands in 1999 to that in 2004?
Ensure brevity in your answer.  0.92. What is the ratio of the Emissions(kt) in United States in 1999 to that in 2004?
Keep it short and to the point. 0.96. What is the ratio of the Emissions(kt) in Rwanda in 1999 to that in 2005?
Provide a succinct answer. 0.97. What is the ratio of the Emissions(kt) of Solomon Islands in 1999 to that in 2005?
Offer a very short reply. 0.92. What is the ratio of the Emissions(kt) of United States in 1999 to that in 2005?
Provide a succinct answer. 0.95. What is the ratio of the Emissions(kt) of Djibouti in 1999 to that in 2006?
Offer a terse response. 1.01. What is the ratio of the Emissions(kt) of Rwanda in 1999 to that in 2006?
Your response must be concise. 0.97. What is the ratio of the Emissions(kt) of Solomon Islands in 1999 to that in 2006?
Offer a terse response. 0.92. What is the ratio of the Emissions(kt) in United States in 1999 to that in 2006?
Provide a short and direct response. 0.97. What is the ratio of the Emissions(kt) in Djibouti in 2000 to that in 2001?
Offer a terse response. 1.11. What is the ratio of the Emissions(kt) in Solomon Islands in 2000 to that in 2001?
Provide a succinct answer. 0.96. What is the ratio of the Emissions(kt) of United States in 2000 to that in 2001?
Offer a very short reply. 1.02. What is the ratio of the Emissions(kt) in Djibouti in 2000 to that in 2002?
Give a very brief answer. 0.89. What is the ratio of the Emissions(kt) in Solomon Islands in 2000 to that in 2002?
Make the answer very short. 0.96. What is the ratio of the Emissions(kt) of United States in 2000 to that in 2002?
Give a very brief answer. 1.01. What is the ratio of the Emissions(kt) of Djibouti in 2000 to that in 2003?
Your answer should be compact. 0.85. What is the ratio of the Emissions(kt) in Rwanda in 2000 to that in 2003?
Keep it short and to the point. 1.01. What is the ratio of the Emissions(kt) of Solomon Islands in 2000 to that in 2003?
Make the answer very short. 0.92. What is the ratio of the Emissions(kt) in United States in 2000 to that in 2003?
Offer a terse response. 1. What is the ratio of the Emissions(kt) of Djibouti in 2000 to that in 2004?
Your answer should be compact. 0.88. What is the ratio of the Emissions(kt) in Rwanda in 2000 to that in 2004?
Provide a short and direct response. 1. What is the ratio of the Emissions(kt) in Solomon Islands in 2000 to that in 2004?
Your answer should be very brief. 0.92. What is the ratio of the Emissions(kt) of United States in 2000 to that in 2004?
Ensure brevity in your answer.  0.99. What is the ratio of the Emissions(kt) of Djibouti in 2000 to that in 2005?
Make the answer very short. 0.86. What is the ratio of the Emissions(kt) of Rwanda in 2000 to that in 2005?
Give a very brief answer. 1. What is the ratio of the Emissions(kt) in Solomon Islands in 2000 to that in 2005?
Your response must be concise. 0.92. What is the ratio of the Emissions(kt) of United States in 2000 to that in 2005?
Provide a succinct answer. 0.98. What is the ratio of the Emissions(kt) in Djibouti in 2000 to that in 2006?
Provide a short and direct response. 0.87. What is the ratio of the Emissions(kt) of Rwanda in 2000 to that in 2006?
Your response must be concise. 1. What is the ratio of the Emissions(kt) in Solomon Islands in 2000 to that in 2006?
Your response must be concise. 0.92. What is the ratio of the Emissions(kt) in Djibouti in 2001 to that in 2002?
Provide a succinct answer. 0.8. What is the ratio of the Emissions(kt) of United States in 2001 to that in 2002?
Your response must be concise. 0.99. What is the ratio of the Emissions(kt) in Djibouti in 2001 to that in 2003?
Your answer should be very brief. 0.76. What is the ratio of the Emissions(kt) of Rwanda in 2001 to that in 2003?
Provide a succinct answer. 1.02. What is the ratio of the Emissions(kt) in Solomon Islands in 2001 to that in 2003?
Make the answer very short. 0.96. What is the ratio of the Emissions(kt) of United States in 2001 to that in 2003?
Ensure brevity in your answer.  0.99. What is the ratio of the Emissions(kt) in Djibouti in 2001 to that in 2004?
Provide a short and direct response. 0.79. What is the ratio of the Emissions(kt) in Solomon Islands in 2001 to that in 2004?
Provide a succinct answer. 0.96. What is the ratio of the Emissions(kt) of United States in 2001 to that in 2004?
Make the answer very short. 0.97. What is the ratio of the Emissions(kt) in Djibouti in 2001 to that in 2005?
Provide a short and direct response. 0.77. What is the ratio of the Emissions(kt) of Rwanda in 2001 to that in 2005?
Offer a terse response. 1.01. What is the ratio of the Emissions(kt) in Solomon Islands in 2001 to that in 2005?
Ensure brevity in your answer.  0.96. What is the ratio of the Emissions(kt) in United States in 2001 to that in 2005?
Offer a terse response. 0.97. What is the ratio of the Emissions(kt) of Djibouti in 2001 to that in 2006?
Your response must be concise. 0.78. What is the ratio of the Emissions(kt) in Rwanda in 2001 to that in 2006?
Make the answer very short. 1.01. What is the ratio of the Emissions(kt) of Solomon Islands in 2001 to that in 2006?
Provide a succinct answer. 0.96. What is the ratio of the Emissions(kt) of Djibouti in 2002 to that in 2003?
Offer a terse response. 0.95. What is the ratio of the Emissions(kt) in Rwanda in 2002 to that in 2003?
Make the answer very short. 1.02. What is the ratio of the Emissions(kt) in Solomon Islands in 2002 to that in 2003?
Your answer should be compact. 0.96. What is the ratio of the Emissions(kt) in United States in 2002 to that in 2003?
Your response must be concise. 0.99. What is the ratio of the Emissions(kt) of Djibouti in 2002 to that in 2004?
Offer a terse response. 0.99. What is the ratio of the Emissions(kt) of Rwanda in 2002 to that in 2004?
Ensure brevity in your answer.  1.01. What is the ratio of the Emissions(kt) of Solomon Islands in 2002 to that in 2004?
Offer a terse response. 0.96. What is the ratio of the Emissions(kt) in United States in 2002 to that in 2004?
Provide a succinct answer. 0.98. What is the ratio of the Emissions(kt) of Djibouti in 2002 to that in 2005?
Your response must be concise. 0.97. What is the ratio of the Emissions(kt) of Rwanda in 2002 to that in 2005?
Your response must be concise. 1.01. What is the ratio of the Emissions(kt) of Solomon Islands in 2002 to that in 2005?
Your answer should be very brief. 0.96. What is the ratio of the Emissions(kt) in United States in 2002 to that in 2005?
Ensure brevity in your answer.  0.97. What is the ratio of the Emissions(kt) of Djibouti in 2002 to that in 2006?
Offer a terse response. 0.97. What is the ratio of the Emissions(kt) in Solomon Islands in 2002 to that in 2006?
Keep it short and to the point. 0.96. What is the ratio of the Emissions(kt) in United States in 2002 to that in 2006?
Offer a terse response. 0.99. What is the ratio of the Emissions(kt) in Djibouti in 2003 to that in 2004?
Give a very brief answer. 1.04. What is the ratio of the Emissions(kt) of Rwanda in 2003 to that in 2004?
Give a very brief answer. 0.99. What is the ratio of the Emissions(kt) in United States in 2003 to that in 2004?
Make the answer very short. 0.99. What is the ratio of the Emissions(kt) of Djibouti in 2003 to that in 2005?
Keep it short and to the point. 1.02. What is the ratio of the Emissions(kt) of Rwanda in 2003 to that in 2005?
Your answer should be very brief. 0.99. What is the ratio of the Emissions(kt) in Djibouti in 2003 to that in 2006?
Offer a very short reply. 1.03. What is the ratio of the Emissions(kt) in Rwanda in 2003 to that in 2006?
Provide a succinct answer. 0.99. What is the ratio of the Emissions(kt) in Djibouti in 2004 to that in 2005?
Provide a short and direct response. 0.97. What is the ratio of the Emissions(kt) in Rwanda in 2004 to that in 2005?
Ensure brevity in your answer.  1. What is the ratio of the Emissions(kt) in United States in 2004 to that in 2005?
Keep it short and to the point. 0.99. What is the ratio of the Emissions(kt) in Djibouti in 2004 to that in 2006?
Offer a terse response. 0.98. What is the ratio of the Emissions(kt) in Solomon Islands in 2004 to that in 2006?
Keep it short and to the point. 1. What is the ratio of the Emissions(kt) in United States in 2004 to that in 2006?
Ensure brevity in your answer.  1.01. What is the ratio of the Emissions(kt) of Djibouti in 2005 to that in 2006?
Your answer should be compact. 1.01. What is the ratio of the Emissions(kt) in Rwanda in 2005 to that in 2006?
Provide a succinct answer. 1. What is the difference between the highest and the second highest Emissions(kt) in Djibouti?
Offer a very short reply. 7.33. What is the difference between the highest and the second highest Emissions(kt) of United States?
Provide a short and direct response. 3.17e+04. What is the difference between the highest and the lowest Emissions(kt) in Djibouti?
Give a very brief answer. 102.68. What is the difference between the highest and the lowest Emissions(kt) of Rwanda?
Offer a very short reply. 22. What is the difference between the highest and the lowest Emissions(kt) in Solomon Islands?
Your answer should be very brief. 14.67. What is the difference between the highest and the lowest Emissions(kt) in United States?
Ensure brevity in your answer.  2.85e+05. 